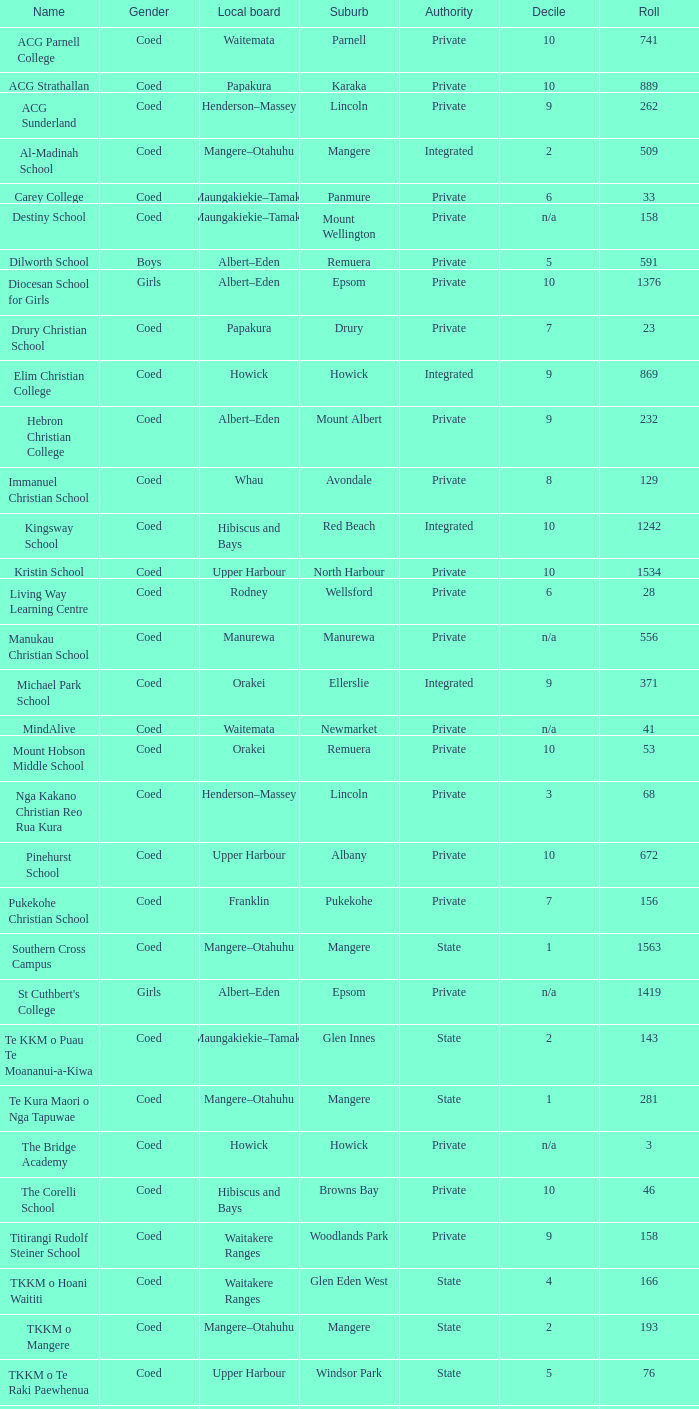What name shows as private authority and hibiscus and bays local board ? The Corelli School. Give me the full table as a dictionary. {'header': ['Name', 'Gender', 'Local board', 'Suburb', 'Authority', 'Decile', 'Roll'], 'rows': [['ACG Parnell College', 'Coed', 'Waitemata', 'Parnell', 'Private', '10', '741'], ['ACG Strathallan', 'Coed', 'Papakura', 'Karaka', 'Private', '10', '889'], ['ACG Sunderland', 'Coed', 'Henderson–Massey', 'Lincoln', 'Private', '9', '262'], ['Al-Madinah School', 'Coed', 'Mangere–Otahuhu', 'Mangere', 'Integrated', '2', '509'], ['Carey College', 'Coed', 'Maungakiekie–Tamaki', 'Panmure', 'Private', '6', '33'], ['Destiny School', 'Coed', 'Maungakiekie–Tamaki', 'Mount Wellington', 'Private', 'n/a', '158'], ['Dilworth School', 'Boys', 'Albert–Eden', 'Remuera', 'Private', '5', '591'], ['Diocesan School for Girls', 'Girls', 'Albert–Eden', 'Epsom', 'Private', '10', '1376'], ['Drury Christian School', 'Coed', 'Papakura', 'Drury', 'Private', '7', '23'], ['Elim Christian College', 'Coed', 'Howick', 'Howick', 'Integrated', '9', '869'], ['Hebron Christian College', 'Coed', 'Albert–Eden', 'Mount Albert', 'Private', '9', '232'], ['Immanuel Christian School', 'Coed', 'Whau', 'Avondale', 'Private', '8', '129'], ['Kingsway School', 'Coed', 'Hibiscus and Bays', 'Red Beach', 'Integrated', '10', '1242'], ['Kristin School', 'Coed', 'Upper Harbour', 'North Harbour', 'Private', '10', '1534'], ['Living Way Learning Centre', 'Coed', 'Rodney', 'Wellsford', 'Private', '6', '28'], ['Manukau Christian School', 'Coed', 'Manurewa', 'Manurewa', 'Private', 'n/a', '556'], ['Michael Park School', 'Coed', 'Orakei', 'Ellerslie', 'Integrated', '9', '371'], ['MindAlive', 'Coed', 'Waitemata', 'Newmarket', 'Private', 'n/a', '41'], ['Mount Hobson Middle School', 'Coed', 'Orakei', 'Remuera', 'Private', '10', '53'], ['Nga Kakano Christian Reo Rua Kura', 'Coed', 'Henderson–Massey', 'Lincoln', 'Private', '3', '68'], ['Pinehurst School', 'Coed', 'Upper Harbour', 'Albany', 'Private', '10', '672'], ['Pukekohe Christian School', 'Coed', 'Franklin', 'Pukekohe', 'Private', '7', '156'], ['Southern Cross Campus', 'Coed', 'Mangere–Otahuhu', 'Mangere', 'State', '1', '1563'], ["St Cuthbert's College", 'Girls', 'Albert–Eden', 'Epsom', 'Private', 'n/a', '1419'], ['Te KKM o Puau Te Moananui-a-Kiwa', 'Coed', 'Maungakiekie–Tamaki', 'Glen Innes', 'State', '2', '143'], ['Te Kura Maori o Nga Tapuwae', 'Coed', 'Mangere–Otahuhu', 'Mangere', 'State', '1', '281'], ['The Bridge Academy', 'Coed', 'Howick', 'Howick', 'Private', 'n/a', '3'], ['The Corelli School', 'Coed', 'Hibiscus and Bays', 'Browns Bay', 'Private', '10', '46'], ['Titirangi Rudolf Steiner School', 'Coed', 'Waitakere Ranges', 'Woodlands Park', 'Private', '9', '158'], ['TKKM o Hoani Waititi', 'Coed', 'Waitakere Ranges', 'Glen Eden West', 'State', '4', '166'], ['TKKM o Mangere', 'Coed', 'Mangere–Otahuhu', 'Mangere', 'State', '2', '193'], ['TKKM o Te Raki Paewhenua', 'Coed', 'Upper Harbour', 'Windsor Park', 'State', '5', '76'], ['Tyndale Park Christian School', 'Coed', 'Howick', 'Flat Bush', 'Private', 'n/a', '120']]} 